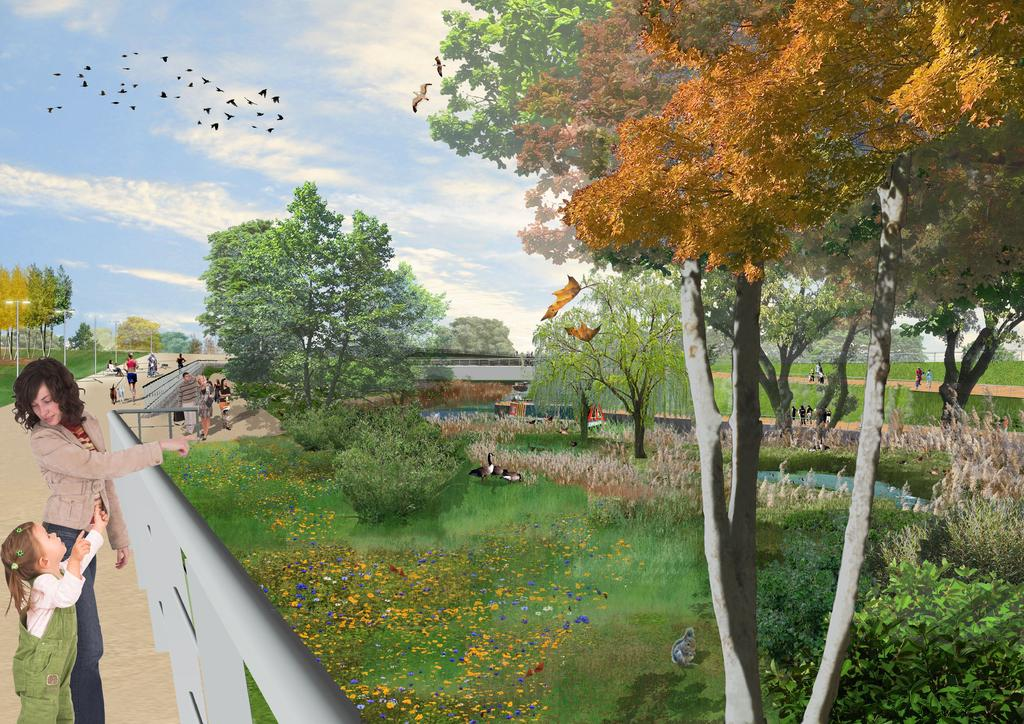Who or what can be seen on the left side of the image? There are people on the left side of the image. What type of vegetation is present in the image? There are trees in the image. What can be seen flying in the sky? Birds are visible in the sky. What is the condition of the sky in the image? The sky is clear in the image. Where is the seashore located in the image? There is no seashore present in the image. Can you tell me how many rabbits are hopping around in the garden in the image? There is no garden or rabbits present in the image. 